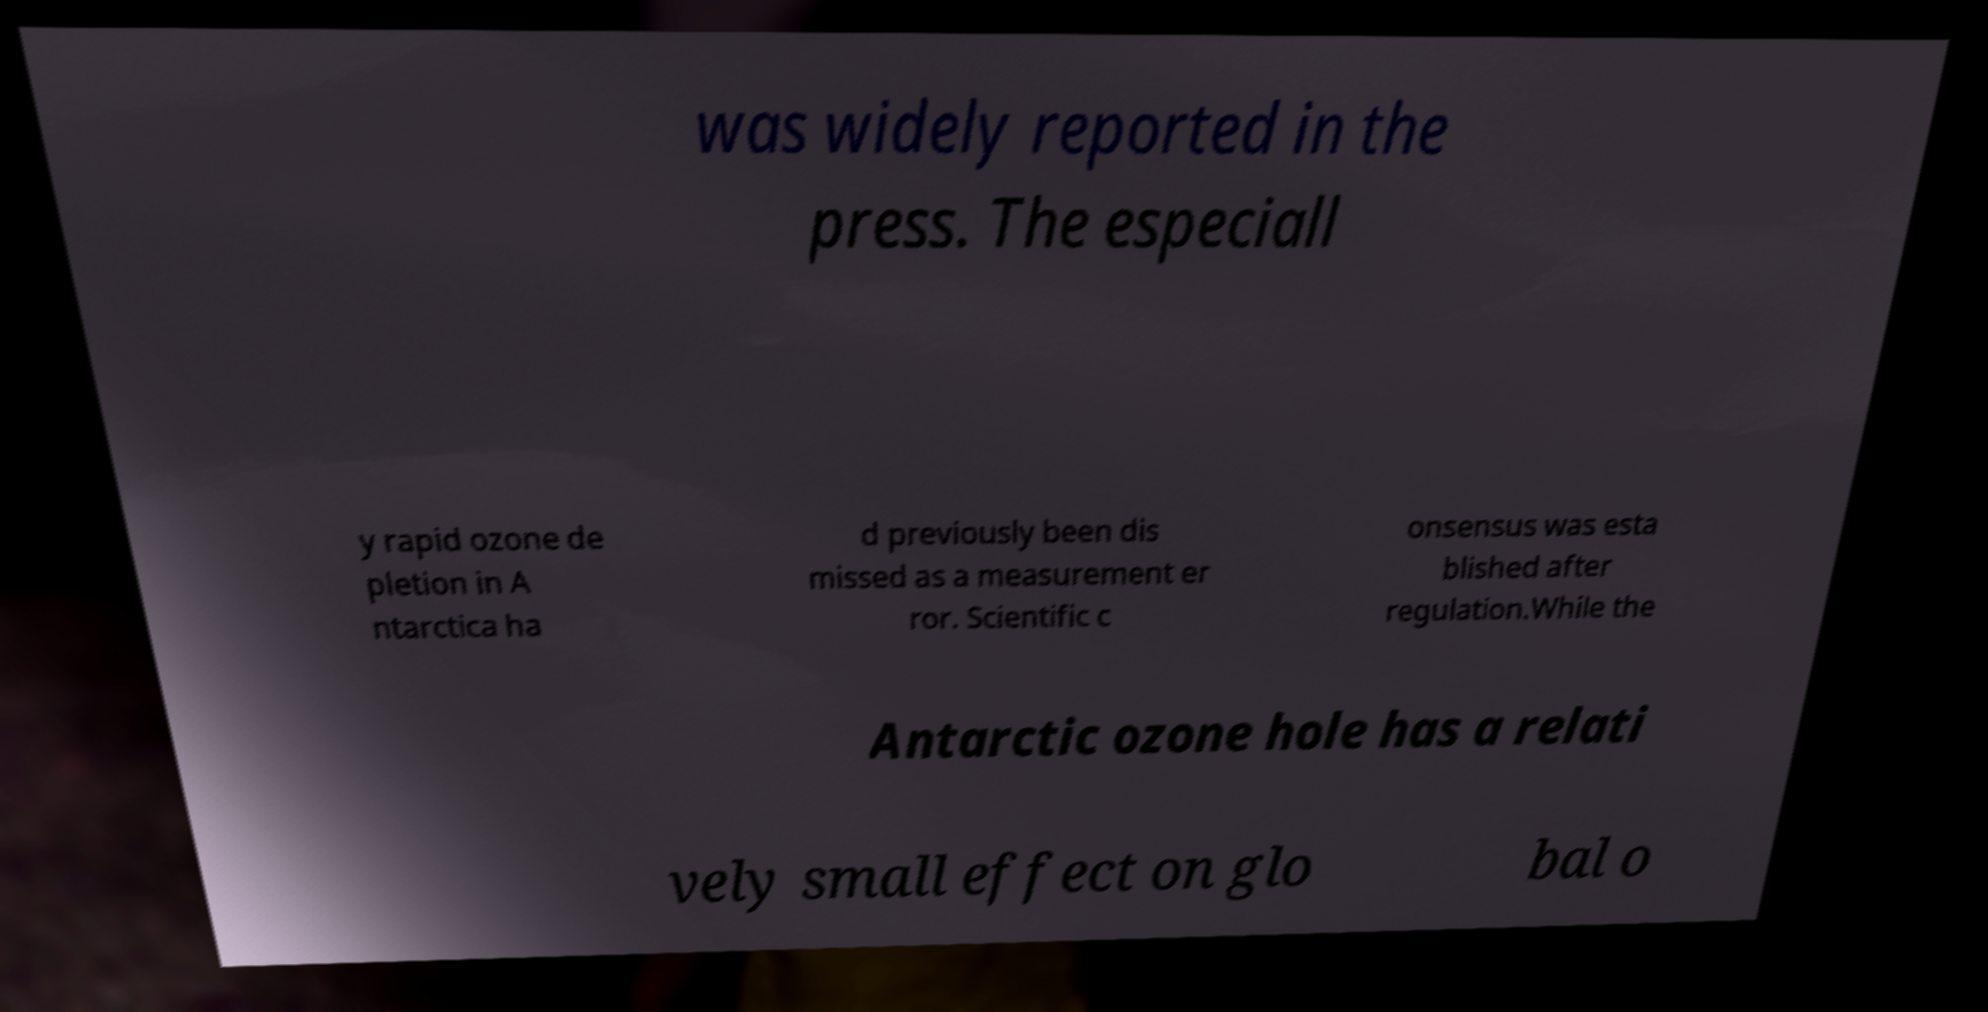Could you assist in decoding the text presented in this image and type it out clearly? was widely reported in the press. The especiall y rapid ozone de pletion in A ntarctica ha d previously been dis missed as a measurement er ror. Scientific c onsensus was esta blished after regulation.While the Antarctic ozone hole has a relati vely small effect on glo bal o 